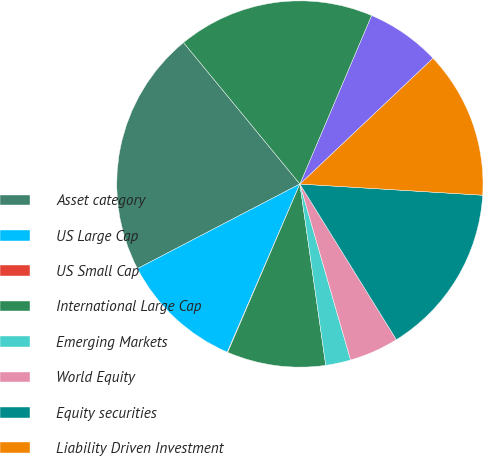Convert chart. <chart><loc_0><loc_0><loc_500><loc_500><pie_chart><fcel>Asset category<fcel>US Large Cap<fcel>US Small Cap<fcel>International Large Cap<fcel>Emerging Markets<fcel>World Equity<fcel>Equity securities<fcel>Liability Driven Investment<fcel>Long-Term Government / Credit<fcel>Fixed income<nl><fcel>21.69%<fcel>10.87%<fcel>0.04%<fcel>8.7%<fcel>2.21%<fcel>4.37%<fcel>15.19%<fcel>13.03%<fcel>6.54%<fcel>17.36%<nl></chart> 